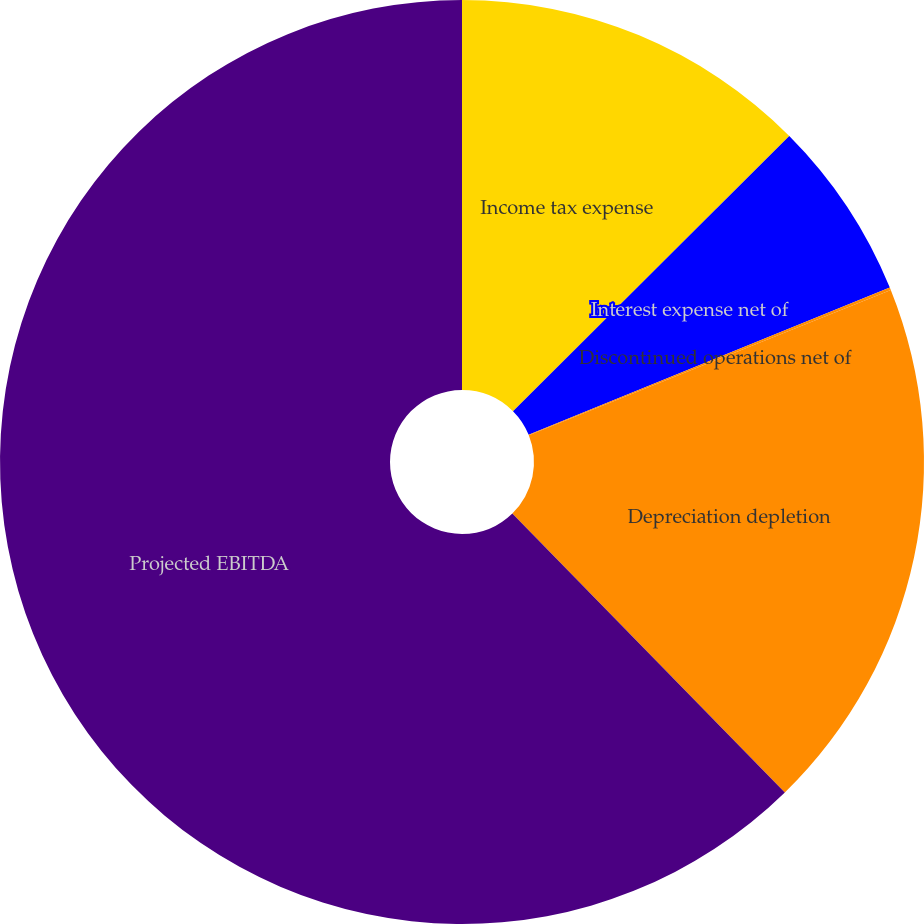<chart> <loc_0><loc_0><loc_500><loc_500><pie_chart><fcel>Income tax expense<fcel>Interest expense net of<fcel>Discontinued operations net of<fcel>Depreciation depletion<fcel>Projected EBITDA<nl><fcel>12.53%<fcel>6.31%<fcel>0.09%<fcel>18.76%<fcel>62.32%<nl></chart> 